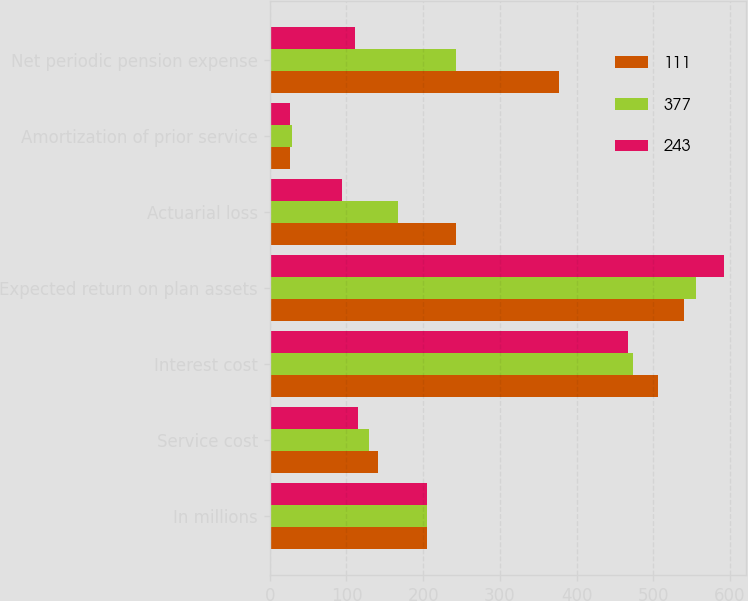<chart> <loc_0><loc_0><loc_500><loc_500><stacked_bar_chart><ecel><fcel>In millions<fcel>Service cost<fcel>Interest cost<fcel>Expected return on plan assets<fcel>Actuarial loss<fcel>Amortization of prior service<fcel>Net periodic pension expense<nl><fcel>111<fcel>205<fcel>141<fcel>506<fcel>540<fcel>243<fcel>27<fcel>377<nl><fcel>377<fcel>205<fcel>129<fcel>474<fcel>556<fcel>167<fcel>29<fcel>243<nl><fcel>243<fcel>205<fcel>115<fcel>467<fcel>592<fcel>94<fcel>27<fcel>111<nl></chart> 